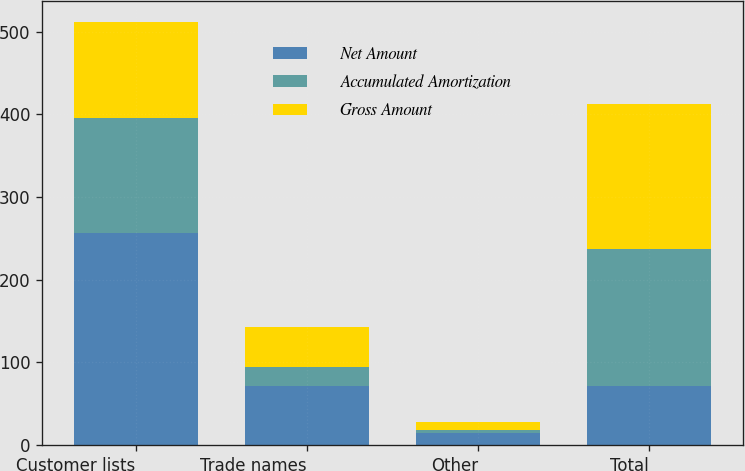Convert chart to OTSL. <chart><loc_0><loc_0><loc_500><loc_500><stacked_bar_chart><ecel><fcel>Customer lists<fcel>Trade names<fcel>Other<fcel>Total<nl><fcel>Net Amount<fcel>255.8<fcel>71<fcel>14.1<fcel>71<nl><fcel>Accumulated Amortization<fcel>139.3<fcel>22.8<fcel>3.8<fcel>165.9<nl><fcel>Gross Amount<fcel>116.5<fcel>48.2<fcel>10.3<fcel>175<nl></chart> 